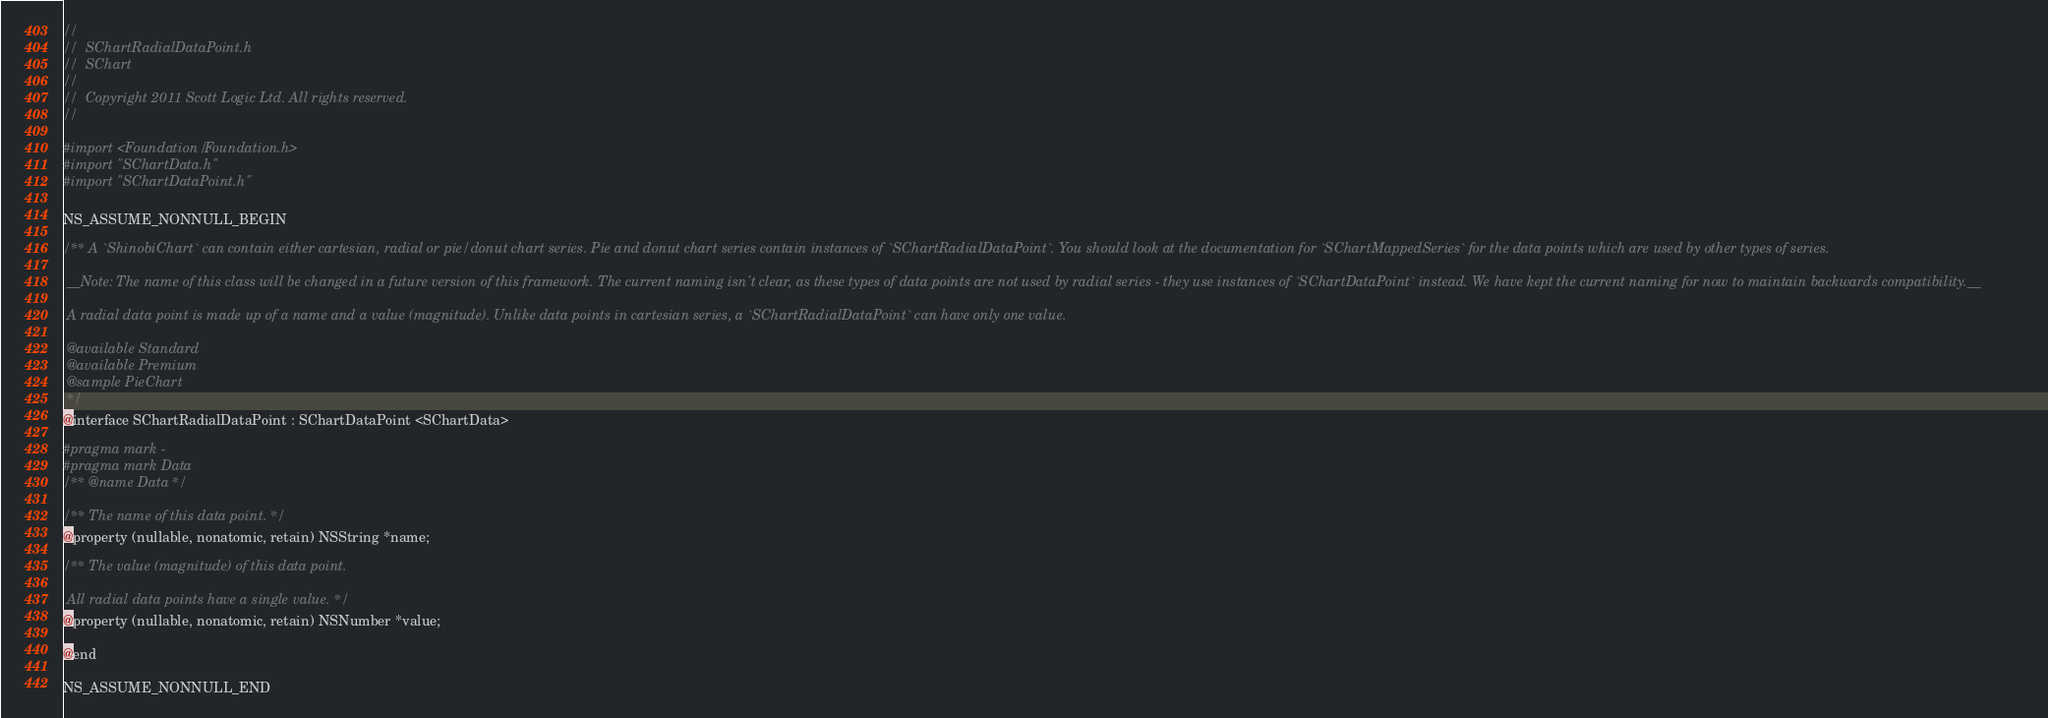<code> <loc_0><loc_0><loc_500><loc_500><_C_>//
//  SChartRadialDataPoint.h
//  SChart
//
//  Copyright 2011 Scott Logic Ltd. All rights reserved.
//

#import <Foundation/Foundation.h>
#import "SChartData.h"
#import "SChartDataPoint.h"

NS_ASSUME_NONNULL_BEGIN

/** A `ShinobiChart` can contain either cartesian, radial or pie/donut chart series. Pie and donut chart series contain instances of `SChartRadialDataPoint`. You should look at the documentation for `SChartMappedSeries` for the data points which are used by other types of series.
 
 __Note: The name of this class will be changed in a future version of this framework. The current naming isn't clear, as these types of data points are not used by radial series - they use instances of `SChartDataPoint` instead. We have kept the current naming for now to maintain backwards compatibility.__
 
 A radial data point is made up of a name and a value (magnitude). Unlike data points in cartesian series, a `SChartRadialDataPoint` can have only one value.
 
 @available Standard
 @available Premium
 @sample PieChart
 */
@interface SChartRadialDataPoint : SChartDataPoint <SChartData>

#pragma mark -
#pragma mark Data
/** @name Data */

/** The name of this data point. */
@property (nullable, nonatomic, retain) NSString *name;

/** The value (magnitude) of this data point.
 
 All radial data points have a single value. */
@property (nullable, nonatomic, retain) NSNumber *value;

@end

NS_ASSUME_NONNULL_END
</code> 